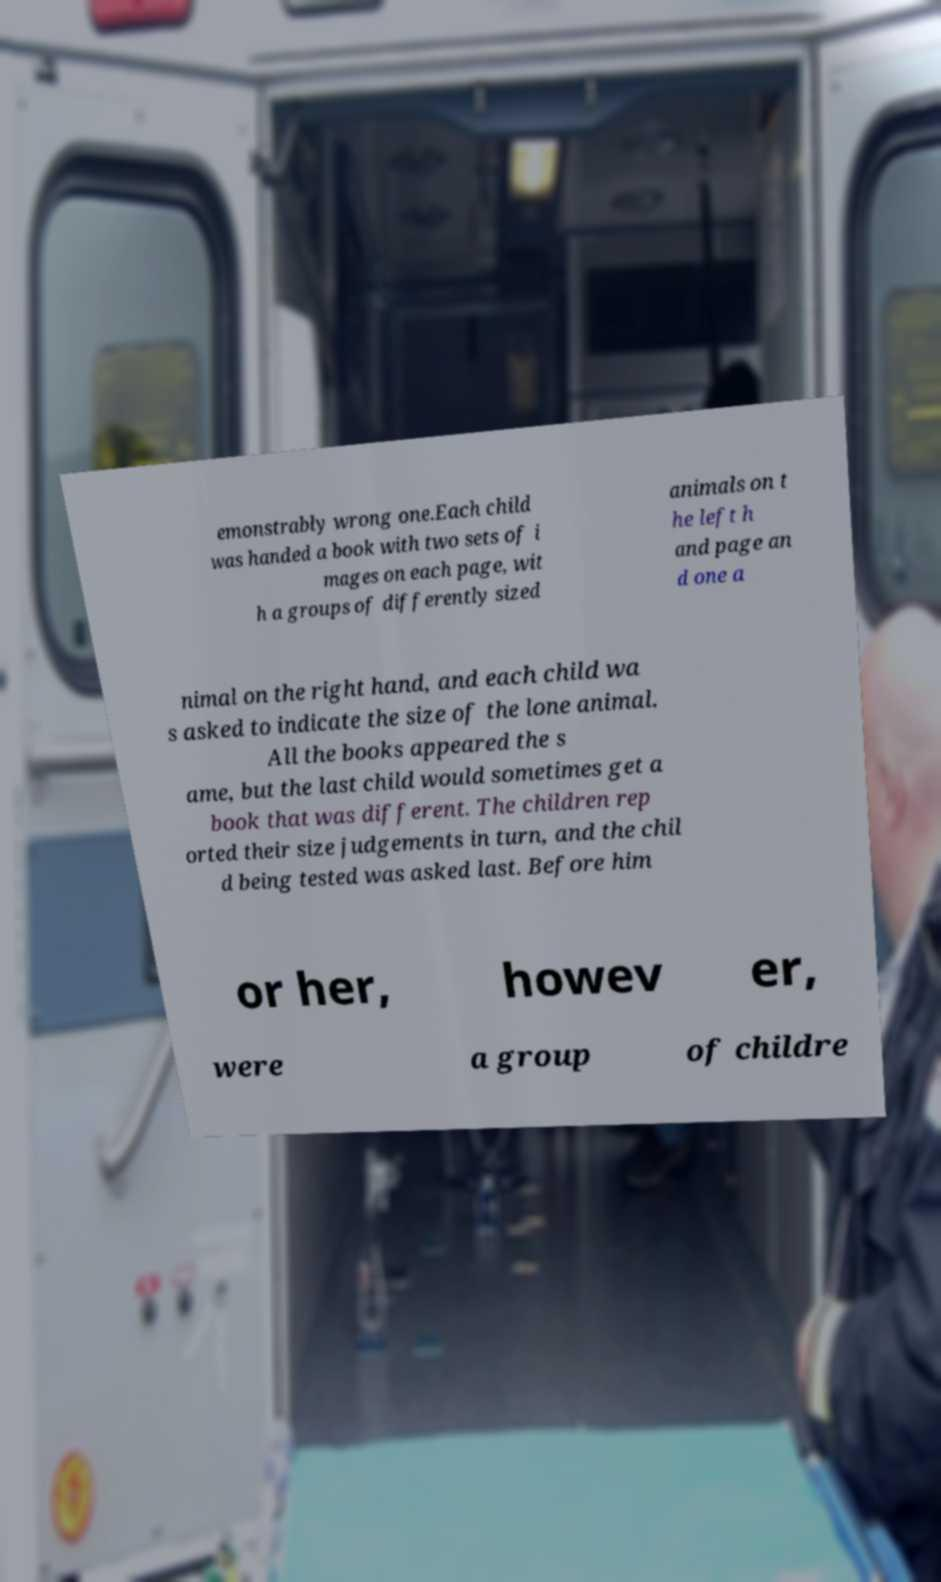I need the written content from this picture converted into text. Can you do that? emonstrably wrong one.Each child was handed a book with two sets of i mages on each page, wit h a groups of differently sized animals on t he left h and page an d one a nimal on the right hand, and each child wa s asked to indicate the size of the lone animal. All the books appeared the s ame, but the last child would sometimes get a book that was different. The children rep orted their size judgements in turn, and the chil d being tested was asked last. Before him or her, howev er, were a group of childre 